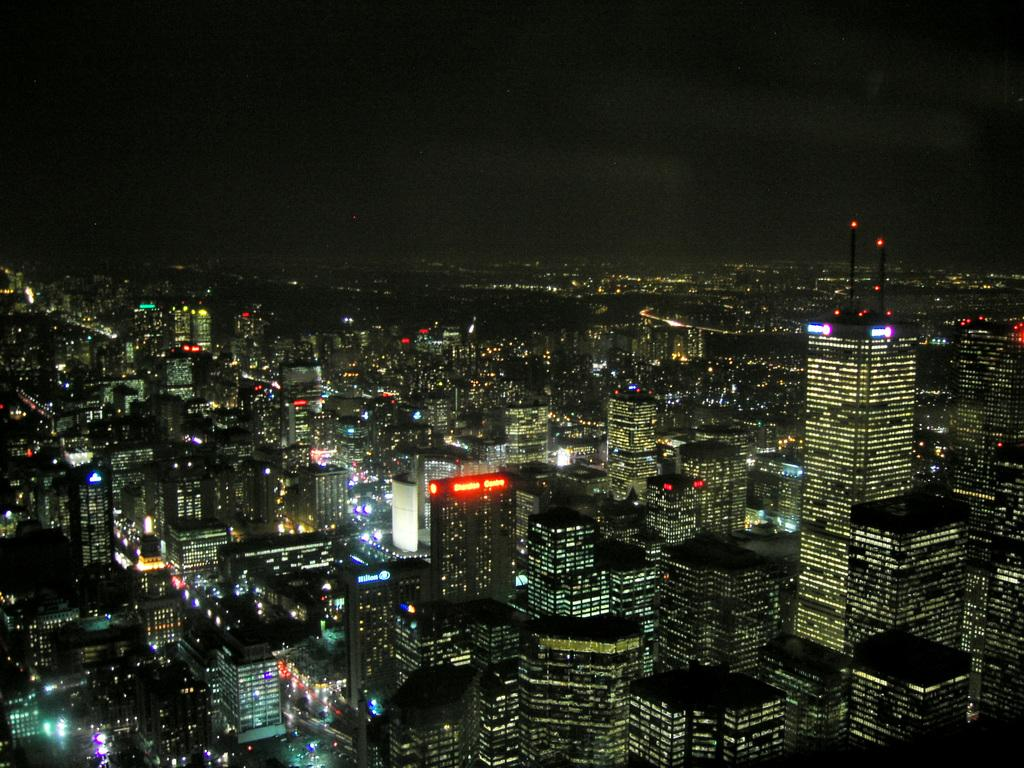What type of structures can be seen in the image? There are many buildings with lights in the image. What specific feature can be observed on some of the buildings? Some of the buildings have LED boards. What can be seen in the background of the image? The sky is visible in the background of the image. How many bananas can be seen on the LED boards in the image? There are no bananas present in the image, as the LED boards are on buildings and not related to fruit. 